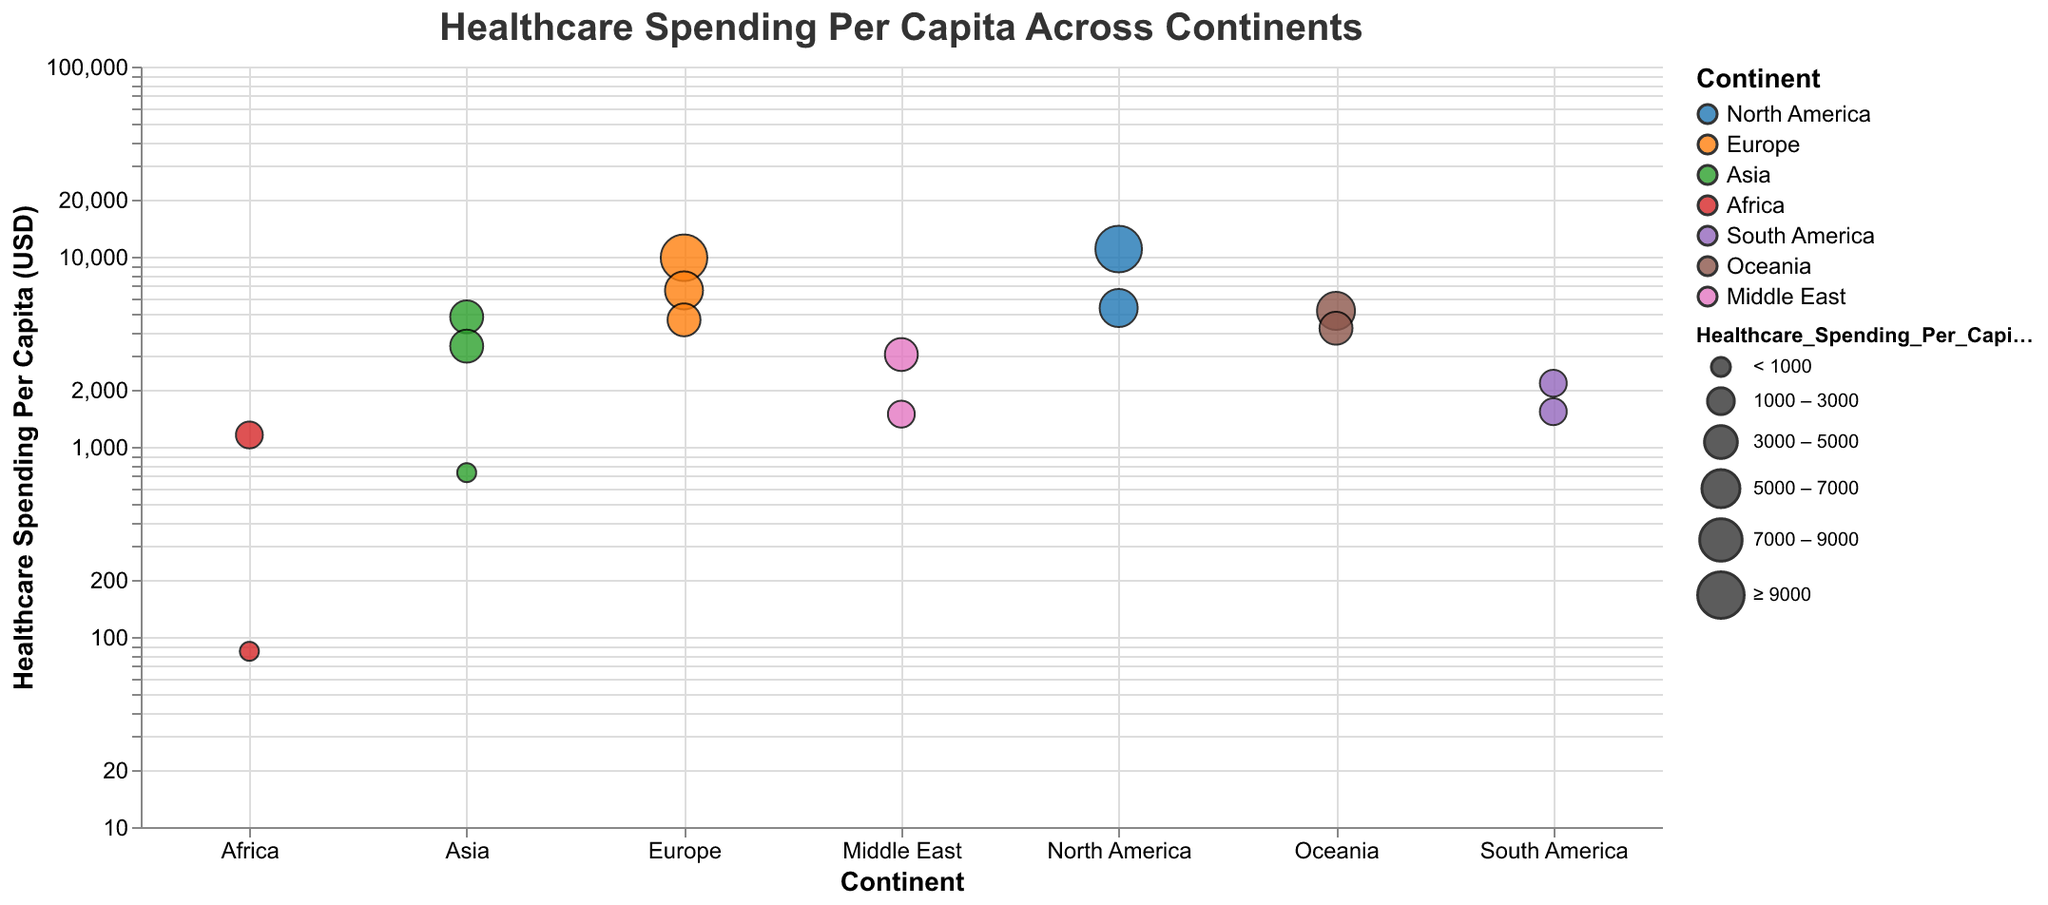What is the title of the figure? The title of the figure is prominently displayed at the top of the plot. It reads "Healthcare Spending Per Capita Across Continents".
Answer: Healthcare Spending Per Capita Across Continents Which country has the highest healthcare spending per capita in the figure? By looking at the size and value of the circles, the United States in North America has the highest healthcare spending per capita, which is 10,966 USD.
Answer: United States What is the approximate difference in healthcare spending per capita between Canada and Germany? The healthcare spending per capita for Canada is 5370 USD and for Germany is 6646 USD. The difference is 6646 - 5370 = 1276 USD.
Answer: 1276 USD Which continent has the most number of countries represented in the plot? Europe has the most number of countries represented, which are Switzerland, Germany, and the United Kingdom. This makes a total of 3 countries.
Answer: Europe List the countries in Asia and their respective healthcare spending per capita. The countries in Asia and their healthcare spending per capita are: Japan (4823 USD), South Korea (3384 USD), and China (731 USD).
Answer: Japan (4823 USD), South Korea (3384 USD), China (731 USD) How does the healthcare spending per capita of Nigeria compare to South Africa? Nigeria has a healthcare spending per capita of 84 USD, while South Africa has 1154 USD. South Africa's spending is significantly higher.
Answer: South Africa's spending is higher Which country has the lowest healthcare spending per capita and from which continent is it? Nigeria from Africa has the lowest healthcare spending per capita, which is 84 USD.
Answer: Nigeria, Africa What is the approximate average healthcare spending per capita for the countries in Oceania? The countries in Oceania are Australia and New Zealand. Their healthcare spending per capita is 5187 USD and 4204 USD, respectively. The average is (5187 + 4204) / 2 = 4695.5 USD.
Answer: 4695.5 USD Between Israel and Saudi Arabia, which country has higher healthcare spending per capita and by how much? Israel's healthcare spending per capita is 3057 USD and Saudi Arabia's is 1485 USD. The difference is 3057 - 1485 = 1572 USD.
Answer: Israel, 1572 USD What is the scale type used for the y-axis, and why might it be used in this plot? The y-axis uses a logarithmic scale as indicated by the code. This scale helps in visualizing data that spans several orders of magnitude by reducing the skew created by large variances.
Answer: Logarithmic scale 